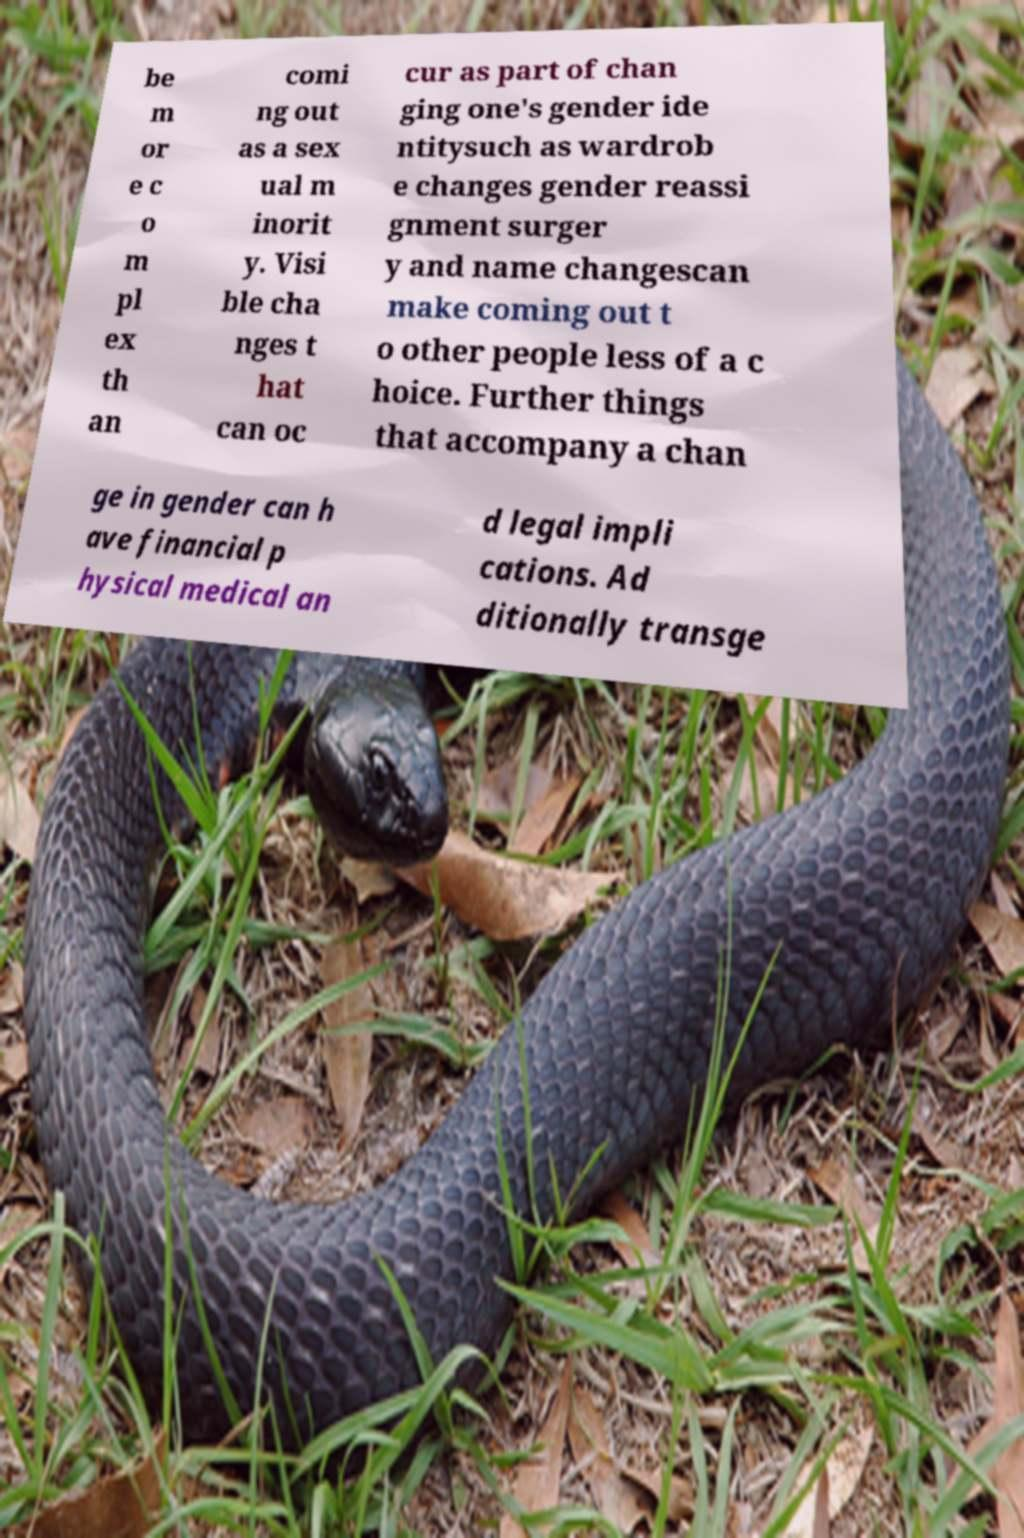Can you read and provide the text displayed in the image?This photo seems to have some interesting text. Can you extract and type it out for me? be m or e c o m pl ex th an comi ng out as a sex ual m inorit y. Visi ble cha nges t hat can oc cur as part of chan ging one's gender ide ntitysuch as wardrob e changes gender reassi gnment surger y and name changescan make coming out t o other people less of a c hoice. Further things that accompany a chan ge in gender can h ave financial p hysical medical an d legal impli cations. Ad ditionally transge 